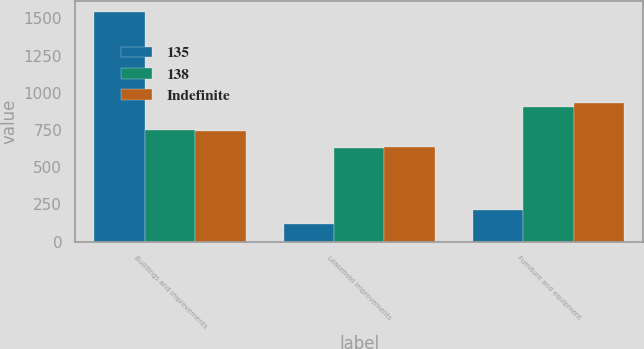<chart> <loc_0><loc_0><loc_500><loc_500><stacked_bar_chart><ecel><fcel>Buildings and improvements<fcel>Leasehold improvements<fcel>Furniture and equipment<nl><fcel>135<fcel>1540<fcel>115<fcel>215<nl><fcel>138<fcel>747<fcel>626<fcel>907<nl><fcel>Indefinite<fcel>741<fcel>633<fcel>931<nl></chart> 